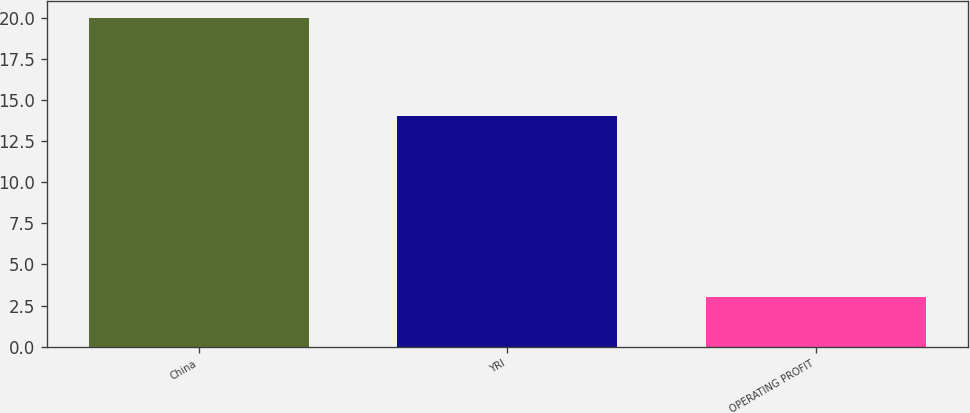Convert chart. <chart><loc_0><loc_0><loc_500><loc_500><bar_chart><fcel>China<fcel>YRI<fcel>OPERATING PROFIT<nl><fcel>20<fcel>14<fcel>3<nl></chart> 